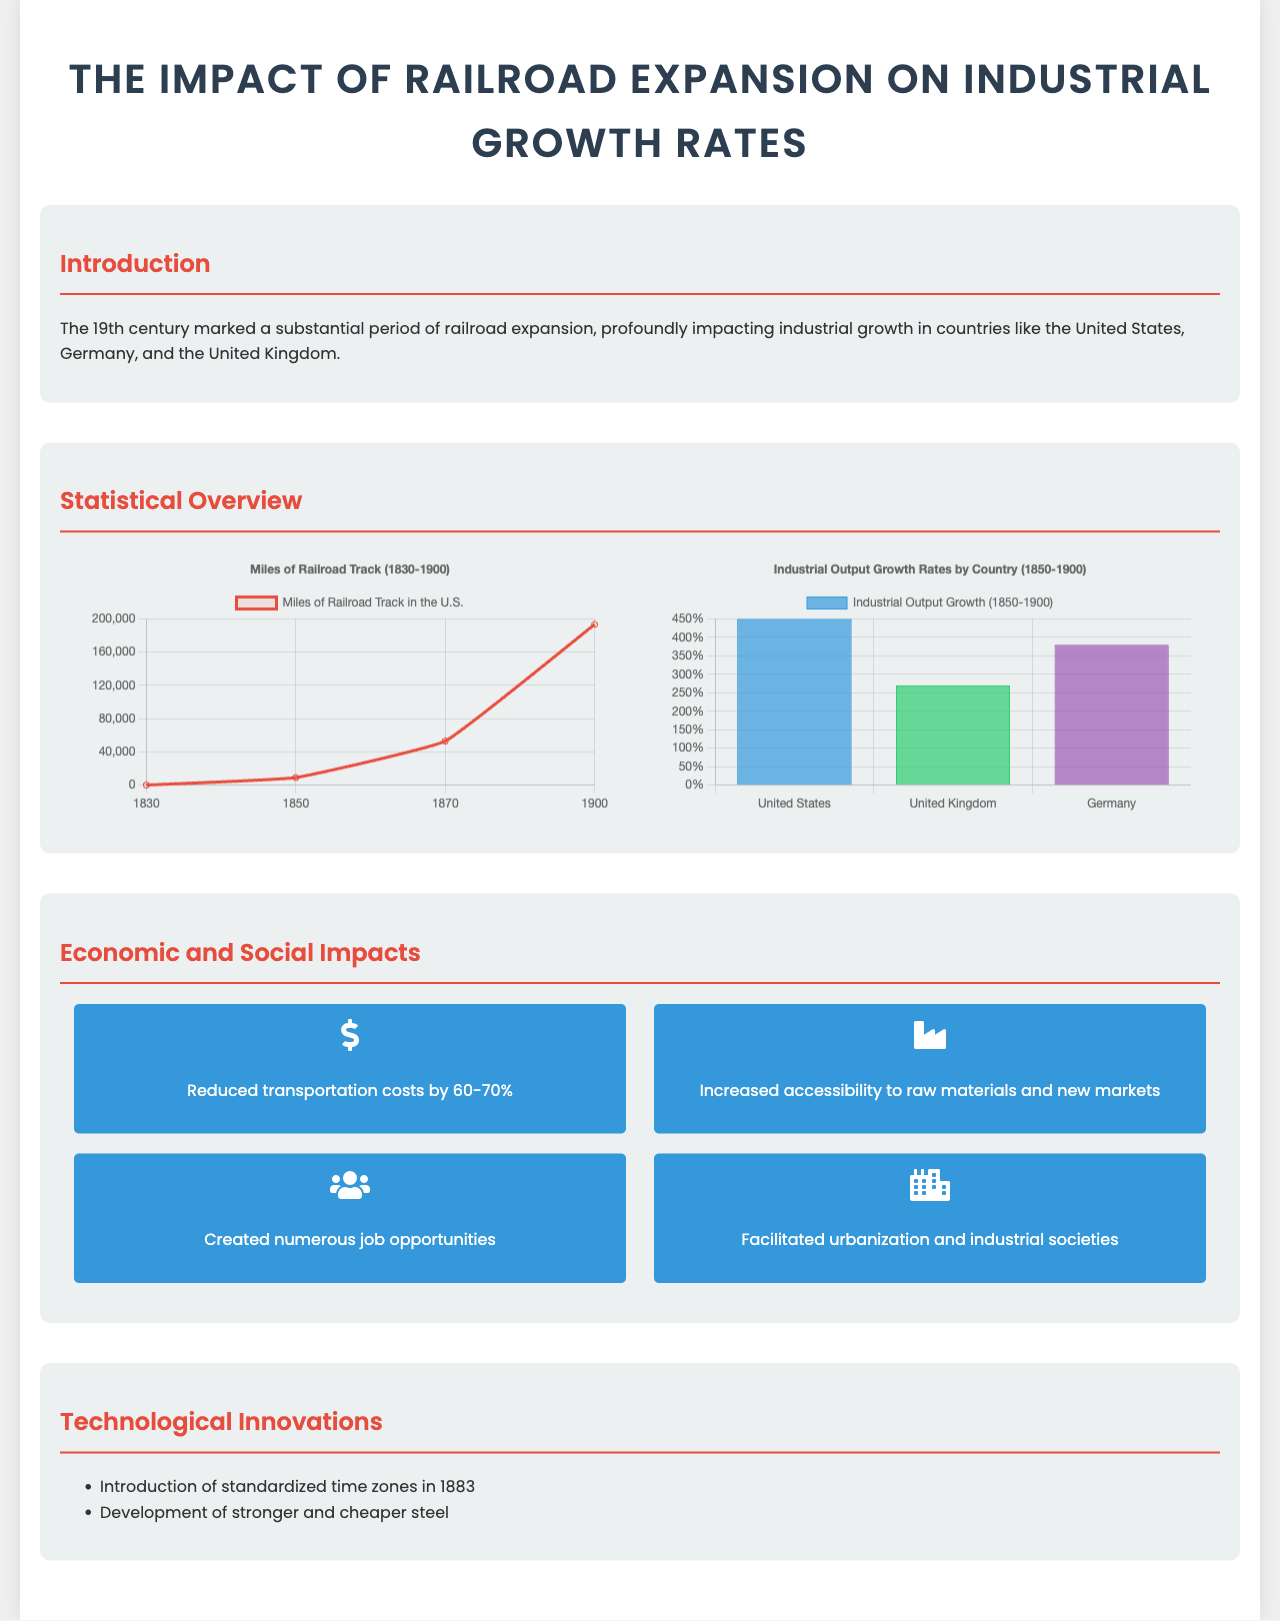What year saw the introduction of standardized time zones? The document states that standardized time zones were introduced in 1883.
Answer: 1883 What was the reduction in transportation costs due to railroad expansion? The document mentions a reduction in transportation costs by 60-70%.
Answer: 60-70% What was the industrial output growth in the United States from 1850 to 1900? The U.S. industrial output growth is given as 450%.
Answer: 450% How many miles of railroad track were there in the U.S. by 1900? The document provides that by 1900, there were 193,346 miles of railroad track in the U.S.
Answer: 193,346 Which country had the lowest industrial output growth rate from 1850 to 1900? The document indicates that the United Kingdom had the lowest industrial output growth at 270%.
Answer: United Kingdom What percentage of job opportunities were created by railroad expansion? While the document does not specify a percentage, it states that numerous job opportunities were created.
Answer: Numerous What two countries are mentioned alongside the United States regarding railroad expansion? The document lists Germany and the United Kingdom as countries impacted by railroad expansion.
Answer: Germany, United Kingdom What sector saw increased access to raw materials due to railroads? The document refers to industrial growth due to increased accessibility to raw materials.
Answer: Industrial sector 